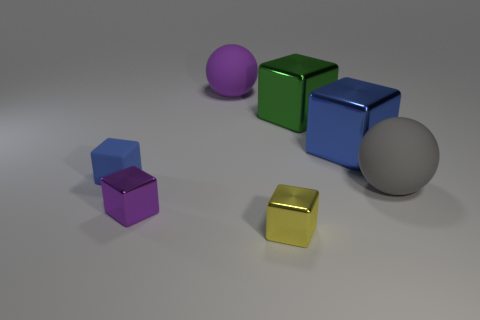There is another thing that is the same shape as the large gray thing; what is its size? The object sharing the same shape as the large gray sphere is a smaller sphere with a purple hue. Its size is comparatively smaller than the large gray sphere. 